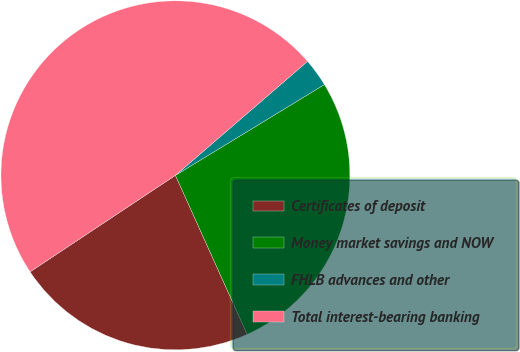<chart> <loc_0><loc_0><loc_500><loc_500><pie_chart><fcel>Certificates of deposit<fcel>Money market savings and NOW<fcel>FHLB advances and other<fcel>Total interest-bearing banking<nl><fcel>22.42%<fcel>26.96%<fcel>2.62%<fcel>48.0%<nl></chart> 